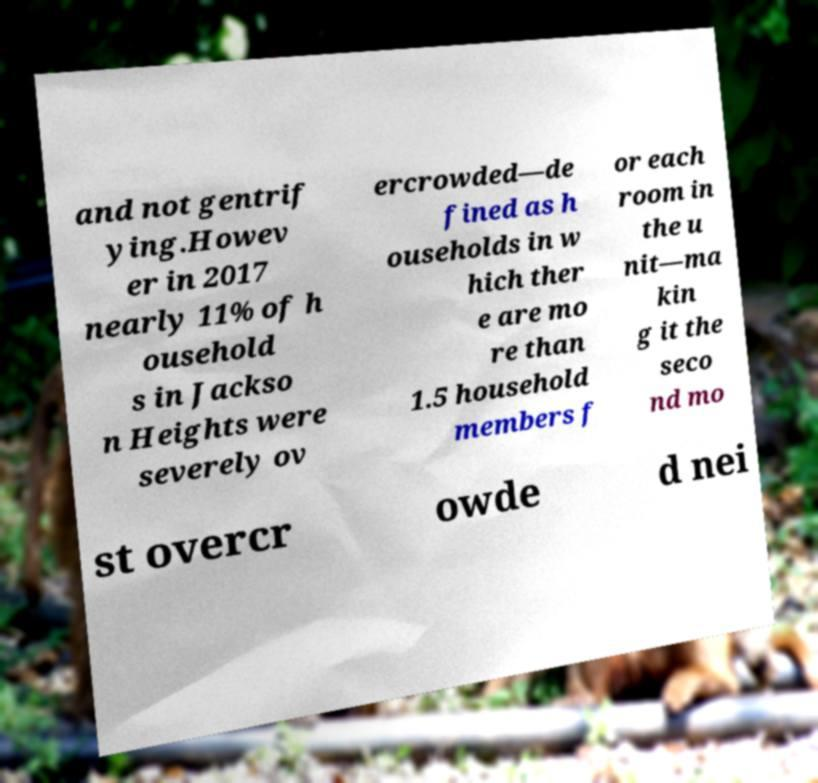I need the written content from this picture converted into text. Can you do that? and not gentrif ying.Howev er in 2017 nearly 11% of h ousehold s in Jackso n Heights were severely ov ercrowded—de fined as h ouseholds in w hich ther e are mo re than 1.5 household members f or each room in the u nit—ma kin g it the seco nd mo st overcr owde d nei 